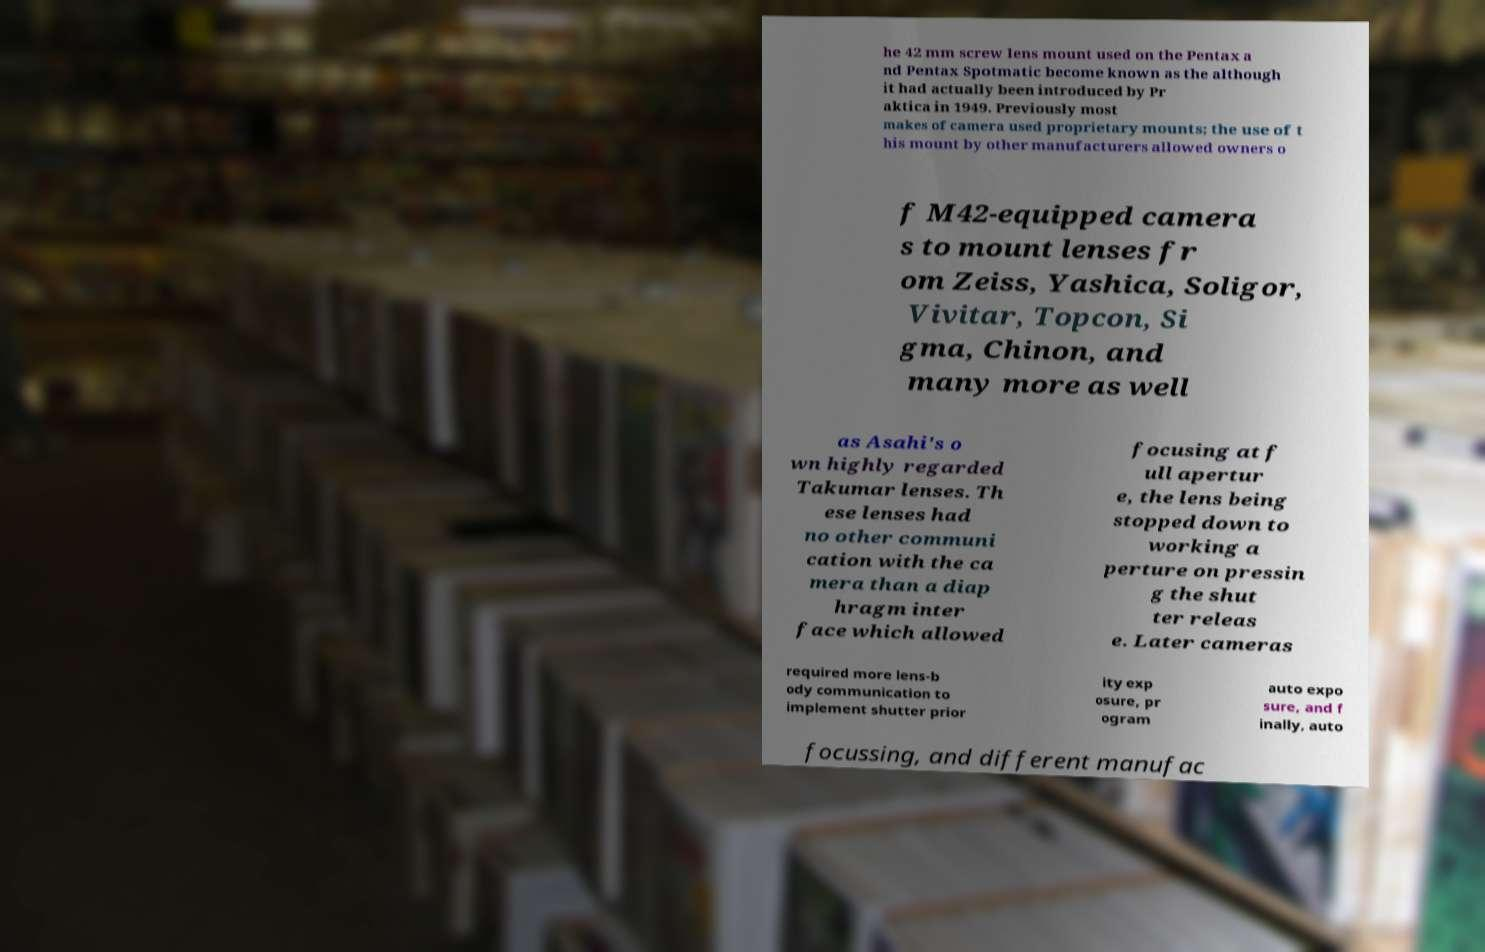Could you extract and type out the text from this image? he 42 mm screw lens mount used on the Pentax a nd Pentax Spotmatic become known as the although it had actually been introduced by Pr aktica in 1949. Previously most makes of camera used proprietary mounts; the use of t his mount by other manufacturers allowed owners o f M42-equipped camera s to mount lenses fr om Zeiss, Yashica, Soligor, Vivitar, Topcon, Si gma, Chinon, and many more as well as Asahi's o wn highly regarded Takumar lenses. Th ese lenses had no other communi cation with the ca mera than a diap hragm inter face which allowed focusing at f ull apertur e, the lens being stopped down to working a perture on pressin g the shut ter releas e. Later cameras required more lens-b ody communication to implement shutter prior ity exp osure, pr ogram auto expo sure, and f inally, auto focussing, and different manufac 